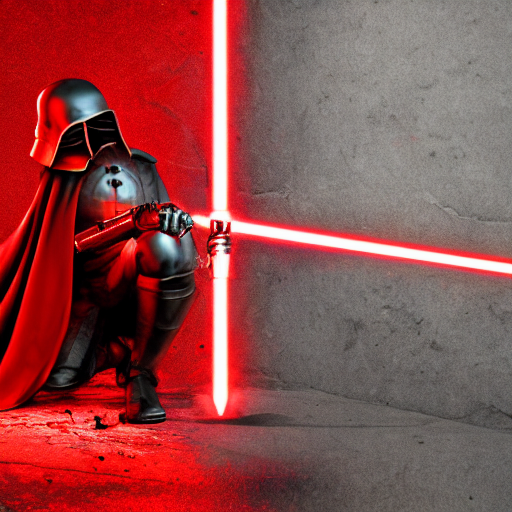Is the lighting overly unnatural?
A. No
B. Yes
Answer with the option's letter from the given choices directly.
 A. 